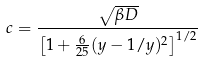Convert formula to latex. <formula><loc_0><loc_0><loc_500><loc_500>c = \frac { \sqrt { \beta D } } { \left [ 1 + \frac { 6 } { 2 5 } ( y - 1 / y ) ^ { 2 } \right ] ^ { 1 / 2 } }</formula> 